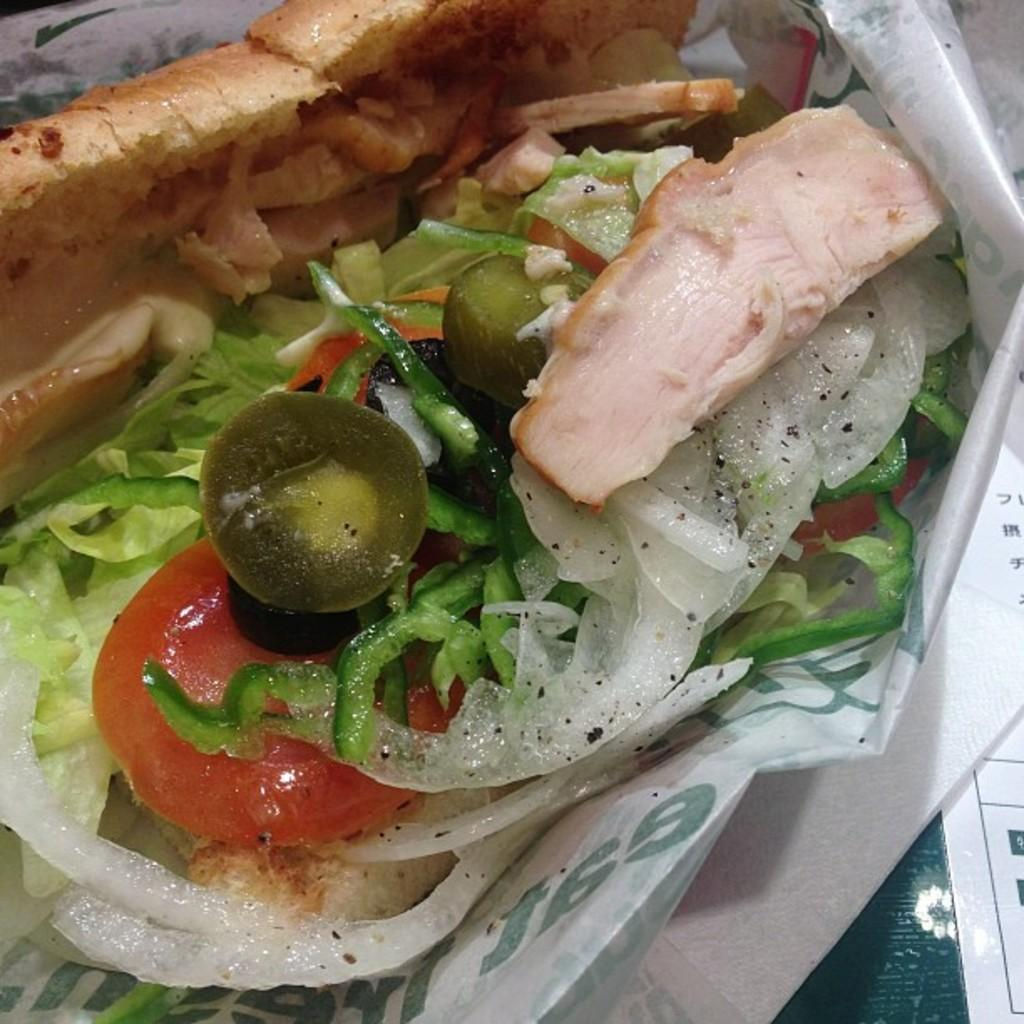What type of objects can be seen in the image? There are food items in the image. How are the food items being stored or presented? The food items are in a cover. What can be found on the right side of the image? There are tissue papers on the right side of the image. Can you see any steam coming from the food items in the image? There is no mention of steam in the provided facts, and therefore it cannot be determined if steam is present in the image. 